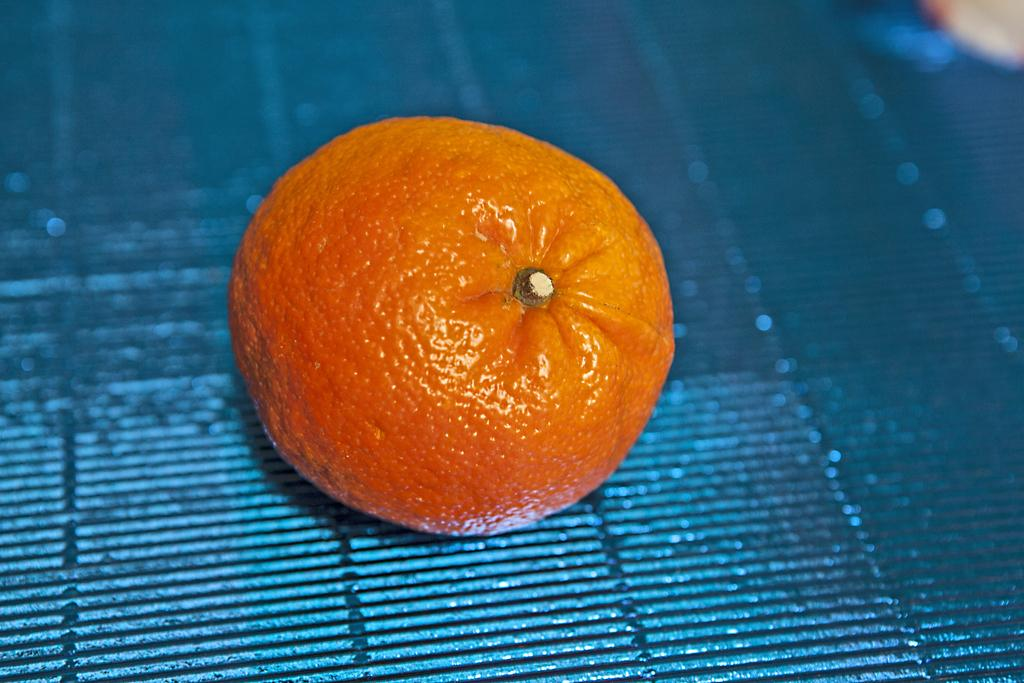What is the main object in the picture? There is an orange in the picture. Where is the orange located? The orange is placed on a grill. What sense is being stimulated by the quartz in the room in the image? There is no quartz or room present in the image; it only features an orange placed on a grill. 